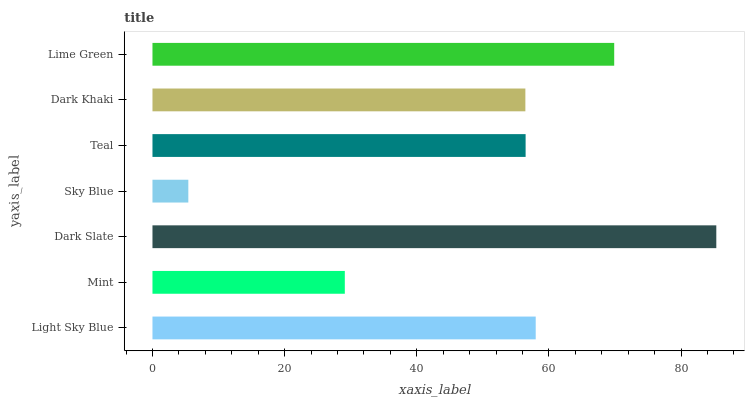Is Sky Blue the minimum?
Answer yes or no. Yes. Is Dark Slate the maximum?
Answer yes or no. Yes. Is Mint the minimum?
Answer yes or no. No. Is Mint the maximum?
Answer yes or no. No. Is Light Sky Blue greater than Mint?
Answer yes or no. Yes. Is Mint less than Light Sky Blue?
Answer yes or no. Yes. Is Mint greater than Light Sky Blue?
Answer yes or no. No. Is Light Sky Blue less than Mint?
Answer yes or no. No. Is Teal the high median?
Answer yes or no. Yes. Is Teal the low median?
Answer yes or no. Yes. Is Mint the high median?
Answer yes or no. No. Is Mint the low median?
Answer yes or no. No. 